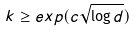<formula> <loc_0><loc_0><loc_500><loc_500>k \geq e x p ( c \sqrt { \log d } )</formula> 